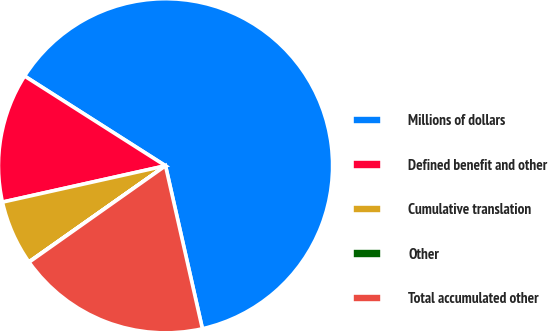Convert chart to OTSL. <chart><loc_0><loc_0><loc_500><loc_500><pie_chart><fcel>Millions of dollars<fcel>Defined benefit and other<fcel>Cumulative translation<fcel>Other<fcel>Total accumulated other<nl><fcel>62.43%<fcel>12.51%<fcel>6.27%<fcel>0.03%<fcel>18.75%<nl></chart> 